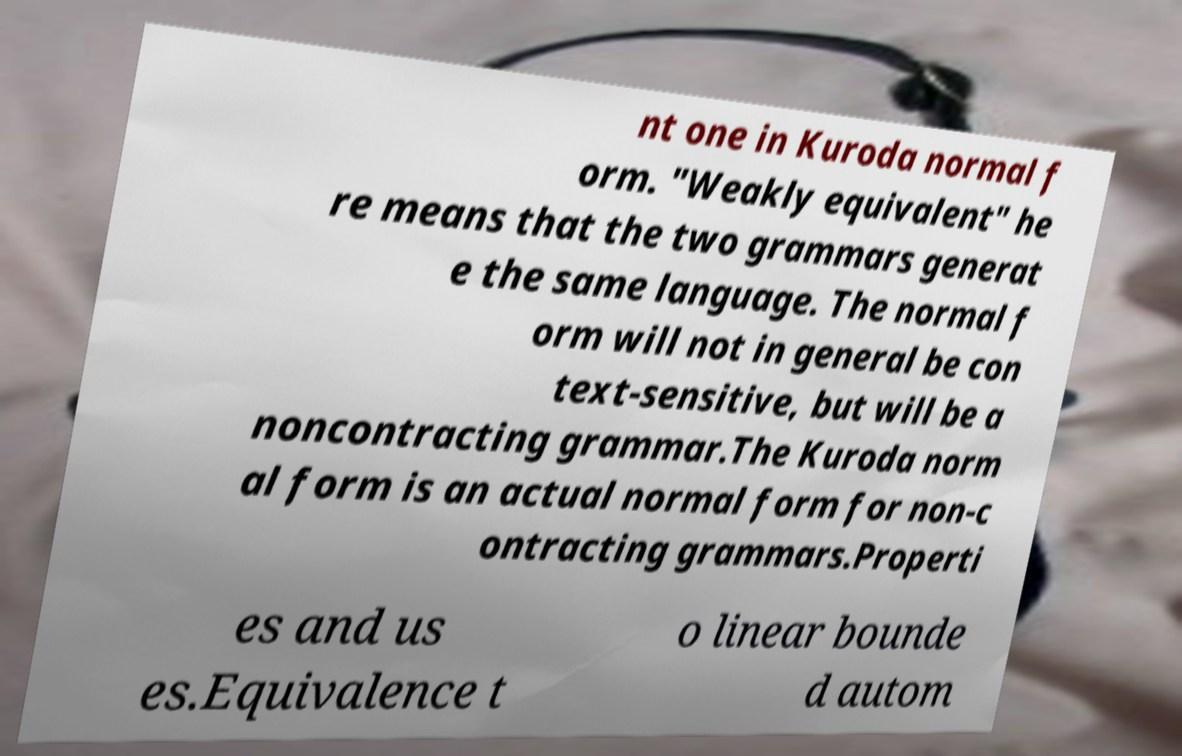What messages or text are displayed in this image? I need them in a readable, typed format. nt one in Kuroda normal f orm. "Weakly equivalent" he re means that the two grammars generat e the same language. The normal f orm will not in general be con text-sensitive, but will be a noncontracting grammar.The Kuroda norm al form is an actual normal form for non-c ontracting grammars.Properti es and us es.Equivalence t o linear bounde d autom 